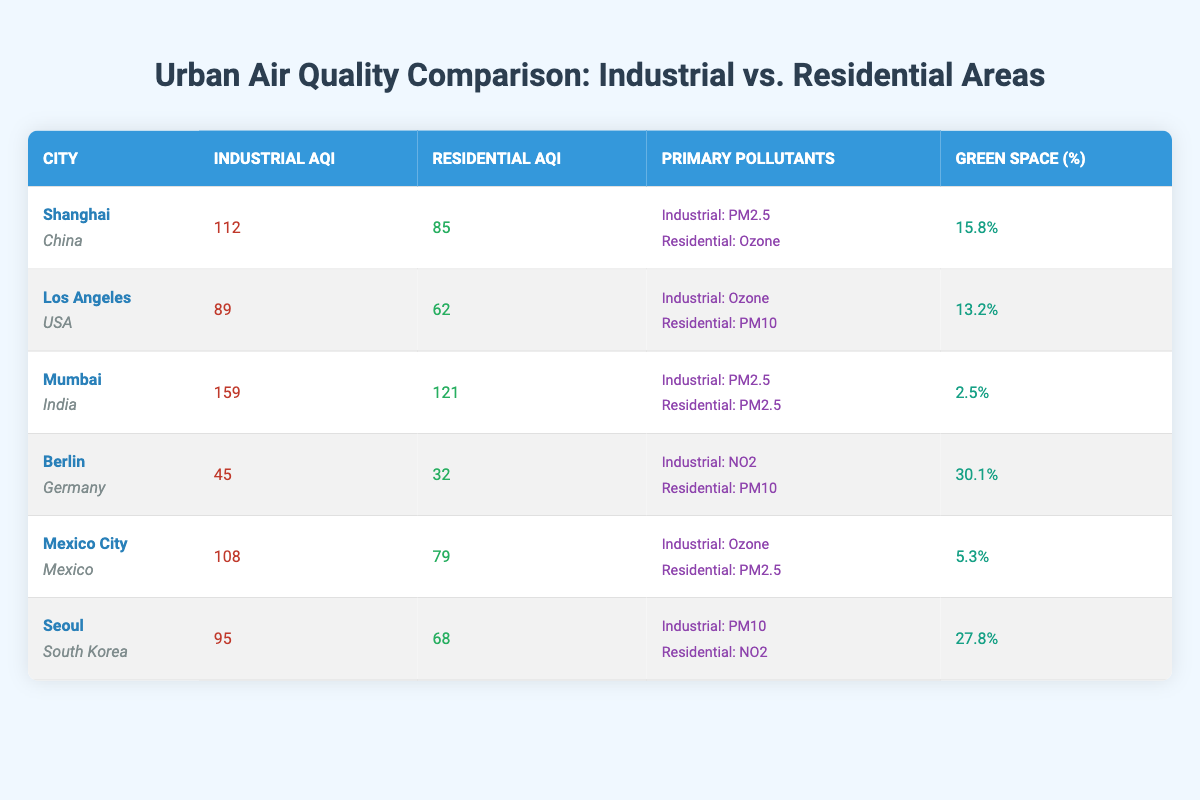What is the industrial AQI for Mumbai? The table shows that the industrial AQI for Mumbai is listed directly under the Industrial AQI column, which is 159.
Answer: 159 Which city has the highest residential AQI? By looking at the Residential AQI column, Mumbai has the highest value listed at 121.
Answer: Mumbai Is the primary pollutant in Los Angeles' industrial area ozone? The primary pollutant for Los Angeles' industrial area is indicated in the table as ozone. Thus, the statement is true.
Answer: Yes What is the difference in AQI between industrial and residential areas in Shanghai? The AQI for industrial areas in Shanghai is 112 and for residential areas is 85. The difference is calculated as 112 - 85 = 27.
Answer: 27 Which city has the lowest green space percentage, and what is that percentage? Scanning the 'Green Space (%)' column, we see that Mumbai has the lowest percentage at 2.5%.
Answer: Mumbai, 2.5% What is the average industrial AQI of all listed cities? To find the average, we sum all the industrial AQI values: (112 + 89 + 159 + 45 + 108 + 95) = 608. There are 6 cities, so the average is 608/6 = 101.33.
Answer: 101.33 Are there any cities where the primary pollutant is PM2.5 in both industrial and residential areas? Reviewing the table, Mumbai is the only city where PM2.5 is listed as the primary pollutant for both industrial and residential areas.
Answer: Yes Which city shows a larger difference between industrial and residential AQI, and what is that difference? The largest difference is noted for Mumbai, which has an industrial AQI of 159 and a residential AQI of 121. The difference is 159 - 121 = 38.
Answer: Mumbai, 38 What is the primary pollutant in the residential area of Berlin? The table states that the primary pollutant in Berlin's residential area is PM10.
Answer: PM10 